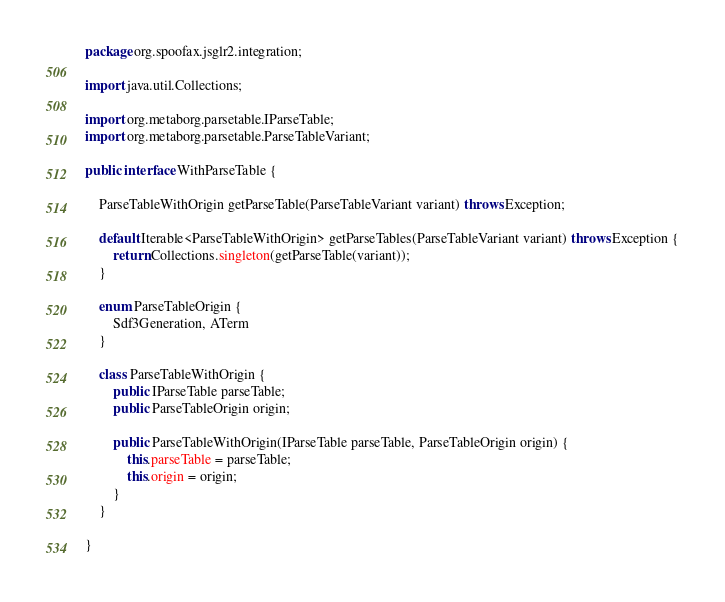<code> <loc_0><loc_0><loc_500><loc_500><_Java_>package org.spoofax.jsglr2.integration;

import java.util.Collections;

import org.metaborg.parsetable.IParseTable;
import org.metaborg.parsetable.ParseTableVariant;

public interface WithParseTable {

    ParseTableWithOrigin getParseTable(ParseTableVariant variant) throws Exception;

    default Iterable<ParseTableWithOrigin> getParseTables(ParseTableVariant variant) throws Exception {
        return Collections.singleton(getParseTable(variant));
    }

    enum ParseTableOrigin {
        Sdf3Generation, ATerm
    }

    class ParseTableWithOrigin {
        public IParseTable parseTable;
        public ParseTableOrigin origin;

        public ParseTableWithOrigin(IParseTable parseTable, ParseTableOrigin origin) {
            this.parseTable = parseTable;
            this.origin = origin;
        }
    }

}
</code> 